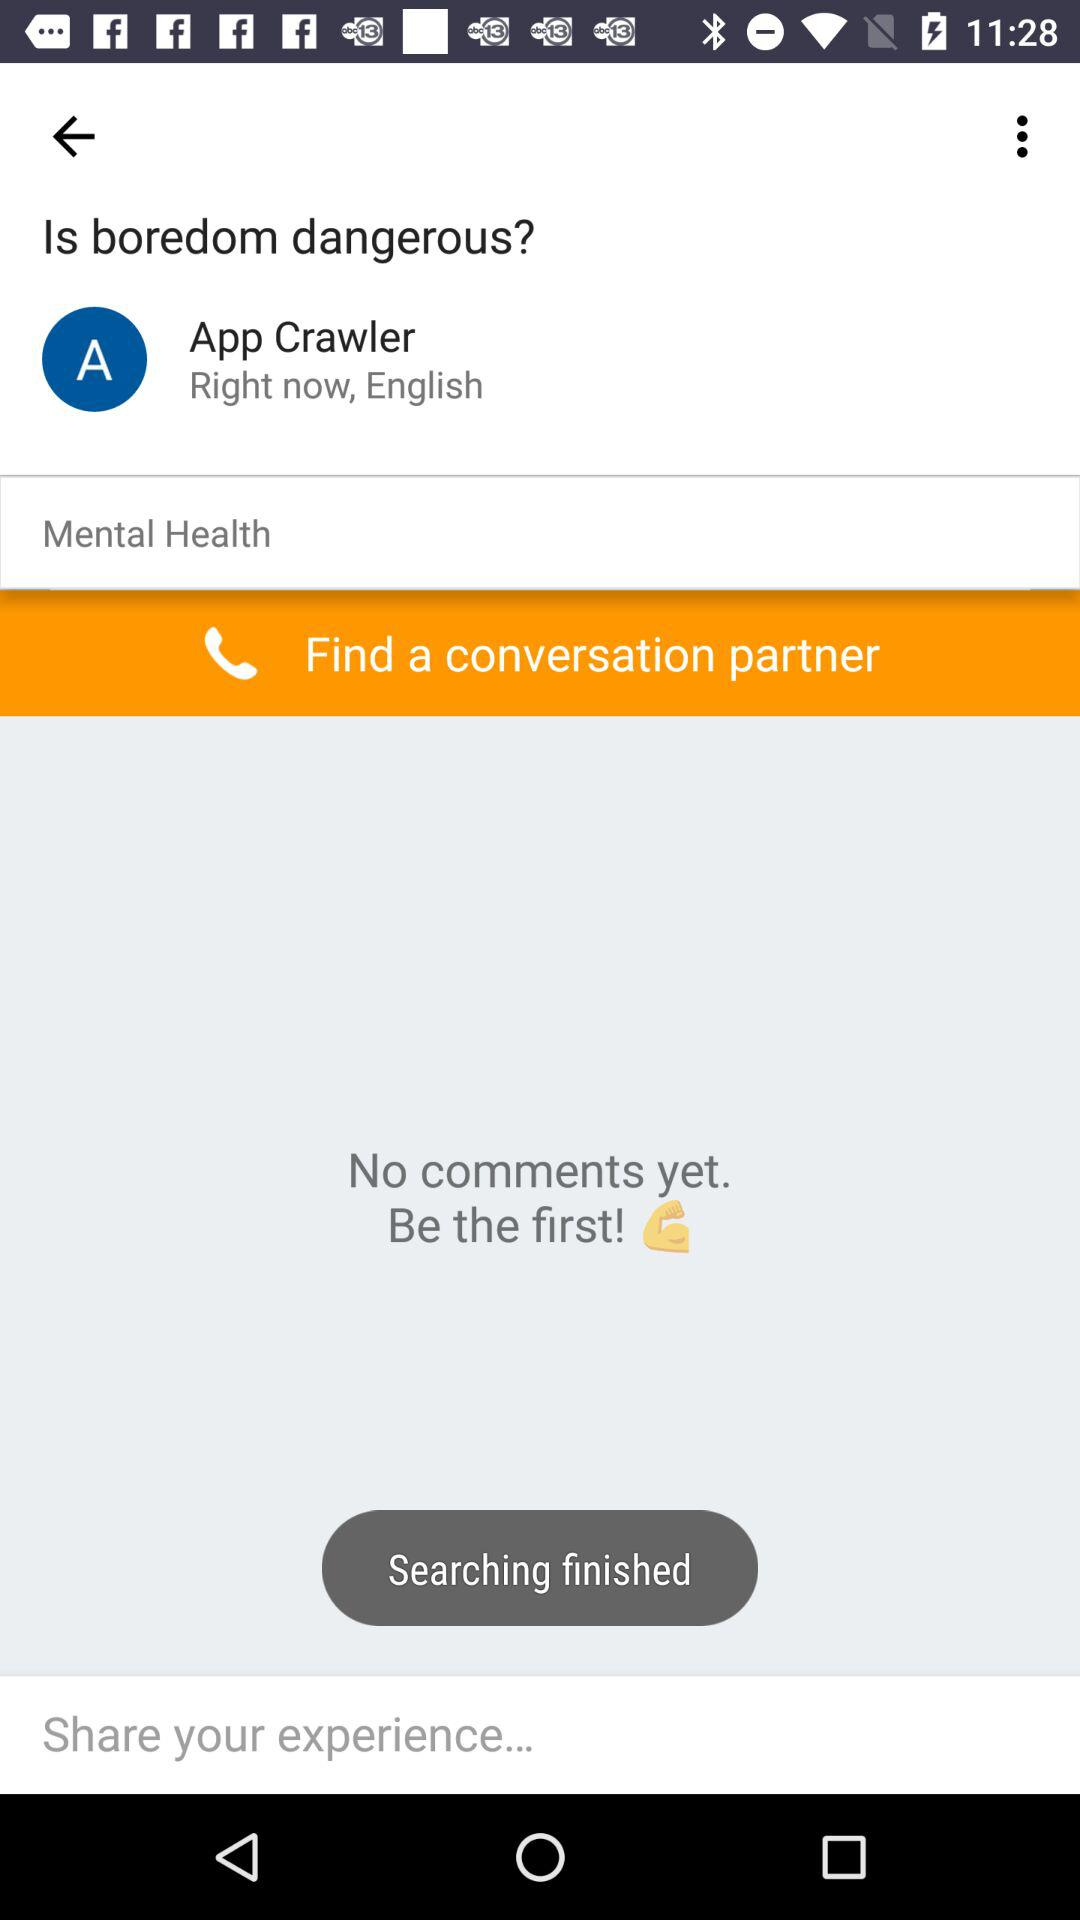If I were to write the first comment, what would be a positive contribution? A positive first comment could be an informative one that provides insights or personal perspective on the effects of boredom, perhaps referencing relevant psychological studies or suggesting coping strategies. 